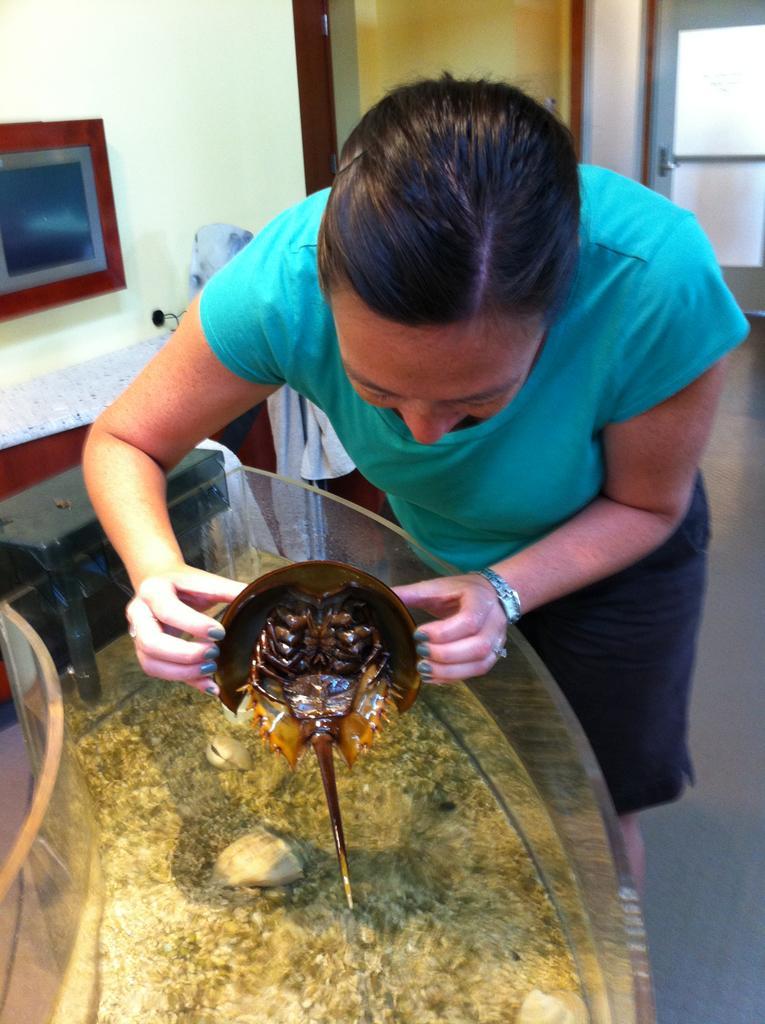Describe this image in one or two sentences. In this image we can see a lady holding an object, in front of her there is an aquarium, in that we can see the water, and rocks, there is a photo frame on the wall, there is a box, also we can see a door. 